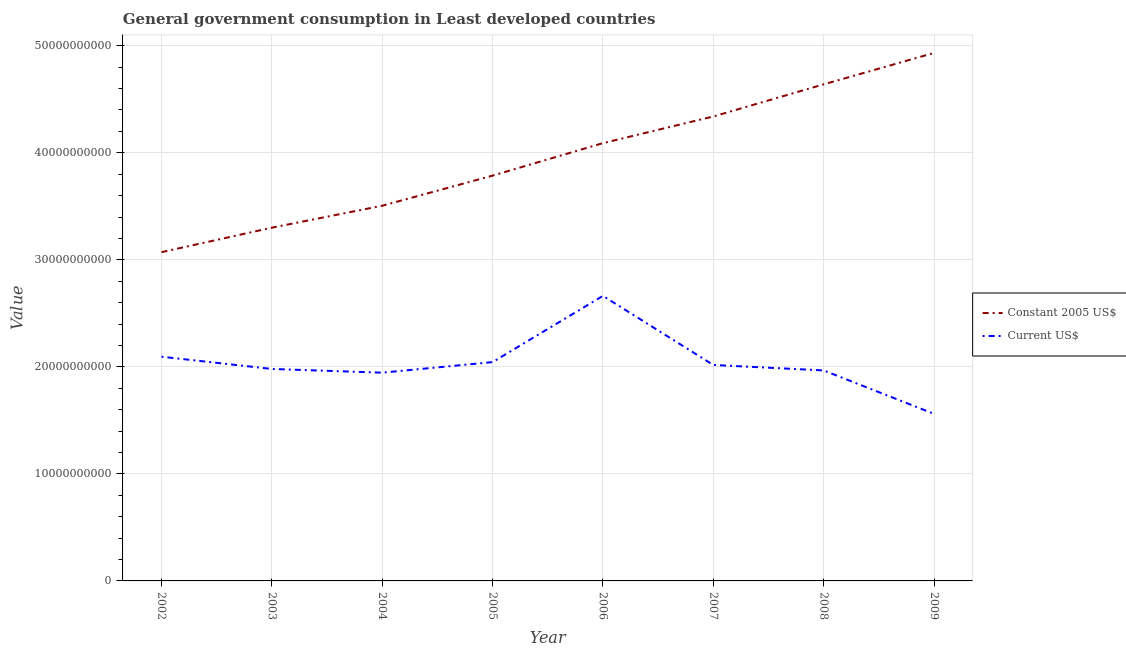How many different coloured lines are there?
Your answer should be compact. 2. What is the value consumed in constant 2005 us$ in 2002?
Offer a very short reply. 3.07e+1. Across all years, what is the maximum value consumed in constant 2005 us$?
Ensure brevity in your answer.  4.93e+1. Across all years, what is the minimum value consumed in current us$?
Your answer should be compact. 1.56e+1. In which year was the value consumed in current us$ maximum?
Your response must be concise. 2006. In which year was the value consumed in constant 2005 us$ minimum?
Your response must be concise. 2002. What is the total value consumed in current us$ in the graph?
Offer a terse response. 1.63e+11. What is the difference between the value consumed in constant 2005 us$ in 2004 and that in 2005?
Keep it short and to the point. -2.81e+09. What is the difference between the value consumed in current us$ in 2007 and the value consumed in constant 2005 us$ in 2008?
Offer a terse response. -2.62e+1. What is the average value consumed in constant 2005 us$ per year?
Your answer should be very brief. 3.96e+1. In the year 2002, what is the difference between the value consumed in current us$ and value consumed in constant 2005 us$?
Ensure brevity in your answer.  -9.77e+09. What is the ratio of the value consumed in current us$ in 2005 to that in 2006?
Give a very brief answer. 0.77. Is the value consumed in constant 2005 us$ in 2004 less than that in 2007?
Provide a short and direct response. Yes. Is the difference between the value consumed in current us$ in 2004 and 2005 greater than the difference between the value consumed in constant 2005 us$ in 2004 and 2005?
Your answer should be compact. Yes. What is the difference between the highest and the second highest value consumed in constant 2005 us$?
Offer a very short reply. 2.94e+09. What is the difference between the highest and the lowest value consumed in current us$?
Your answer should be compact. 1.10e+1. In how many years, is the value consumed in constant 2005 us$ greater than the average value consumed in constant 2005 us$ taken over all years?
Ensure brevity in your answer.  4. Is the sum of the value consumed in constant 2005 us$ in 2004 and 2007 greater than the maximum value consumed in current us$ across all years?
Offer a terse response. Yes. Is the value consumed in current us$ strictly less than the value consumed in constant 2005 us$ over the years?
Ensure brevity in your answer.  Yes. What is the title of the graph?
Your answer should be very brief. General government consumption in Least developed countries. What is the label or title of the X-axis?
Ensure brevity in your answer.  Year. What is the label or title of the Y-axis?
Keep it short and to the point. Value. What is the Value in Constant 2005 US$ in 2002?
Provide a short and direct response. 3.07e+1. What is the Value of Current US$ in 2002?
Your answer should be very brief. 2.09e+1. What is the Value in Constant 2005 US$ in 2003?
Your answer should be compact. 3.30e+1. What is the Value of Current US$ in 2003?
Provide a succinct answer. 1.98e+1. What is the Value in Constant 2005 US$ in 2004?
Offer a terse response. 3.51e+1. What is the Value of Current US$ in 2004?
Your answer should be very brief. 1.95e+1. What is the Value of Constant 2005 US$ in 2005?
Provide a short and direct response. 3.79e+1. What is the Value in Current US$ in 2005?
Your answer should be compact. 2.04e+1. What is the Value in Constant 2005 US$ in 2006?
Your answer should be compact. 4.09e+1. What is the Value of Current US$ in 2006?
Your answer should be compact. 2.66e+1. What is the Value of Constant 2005 US$ in 2007?
Your answer should be very brief. 4.34e+1. What is the Value in Current US$ in 2007?
Your answer should be compact. 2.02e+1. What is the Value of Constant 2005 US$ in 2008?
Give a very brief answer. 4.64e+1. What is the Value in Current US$ in 2008?
Your answer should be compact. 1.97e+1. What is the Value of Constant 2005 US$ in 2009?
Provide a short and direct response. 4.93e+1. What is the Value in Current US$ in 2009?
Your answer should be compact. 1.56e+1. Across all years, what is the maximum Value in Constant 2005 US$?
Give a very brief answer. 4.93e+1. Across all years, what is the maximum Value in Current US$?
Offer a terse response. 2.66e+1. Across all years, what is the minimum Value in Constant 2005 US$?
Offer a very short reply. 3.07e+1. Across all years, what is the minimum Value in Current US$?
Give a very brief answer. 1.56e+1. What is the total Value in Constant 2005 US$ in the graph?
Your answer should be compact. 3.17e+11. What is the total Value in Current US$ in the graph?
Keep it short and to the point. 1.63e+11. What is the difference between the Value of Constant 2005 US$ in 2002 and that in 2003?
Provide a succinct answer. -2.29e+09. What is the difference between the Value of Current US$ in 2002 and that in 2003?
Give a very brief answer. 1.14e+09. What is the difference between the Value in Constant 2005 US$ in 2002 and that in 2004?
Your response must be concise. -4.34e+09. What is the difference between the Value in Current US$ in 2002 and that in 2004?
Your response must be concise. 1.49e+09. What is the difference between the Value of Constant 2005 US$ in 2002 and that in 2005?
Make the answer very short. -7.15e+09. What is the difference between the Value of Current US$ in 2002 and that in 2005?
Ensure brevity in your answer.  5.04e+08. What is the difference between the Value in Constant 2005 US$ in 2002 and that in 2006?
Provide a short and direct response. -1.02e+1. What is the difference between the Value in Current US$ in 2002 and that in 2006?
Offer a very short reply. -5.68e+09. What is the difference between the Value of Constant 2005 US$ in 2002 and that in 2007?
Give a very brief answer. -1.27e+1. What is the difference between the Value of Current US$ in 2002 and that in 2007?
Ensure brevity in your answer.  7.71e+08. What is the difference between the Value of Constant 2005 US$ in 2002 and that in 2008?
Provide a short and direct response. -1.57e+1. What is the difference between the Value in Current US$ in 2002 and that in 2008?
Your answer should be compact. 1.28e+09. What is the difference between the Value in Constant 2005 US$ in 2002 and that in 2009?
Ensure brevity in your answer.  -1.86e+1. What is the difference between the Value of Current US$ in 2002 and that in 2009?
Your answer should be very brief. 5.34e+09. What is the difference between the Value of Constant 2005 US$ in 2003 and that in 2004?
Provide a succinct answer. -2.05e+09. What is the difference between the Value in Current US$ in 2003 and that in 2004?
Your answer should be very brief. 3.47e+08. What is the difference between the Value in Constant 2005 US$ in 2003 and that in 2005?
Provide a short and direct response. -4.86e+09. What is the difference between the Value of Current US$ in 2003 and that in 2005?
Your answer should be compact. -6.39e+08. What is the difference between the Value in Constant 2005 US$ in 2003 and that in 2006?
Your response must be concise. -7.90e+09. What is the difference between the Value in Current US$ in 2003 and that in 2006?
Your answer should be compact. -6.83e+09. What is the difference between the Value in Constant 2005 US$ in 2003 and that in 2007?
Provide a short and direct response. -1.04e+1. What is the difference between the Value of Current US$ in 2003 and that in 2007?
Offer a terse response. -3.72e+08. What is the difference between the Value of Constant 2005 US$ in 2003 and that in 2008?
Your response must be concise. -1.34e+1. What is the difference between the Value in Current US$ in 2003 and that in 2008?
Provide a succinct answer. 1.39e+08. What is the difference between the Value in Constant 2005 US$ in 2003 and that in 2009?
Make the answer very short. -1.63e+1. What is the difference between the Value of Current US$ in 2003 and that in 2009?
Offer a very short reply. 4.20e+09. What is the difference between the Value of Constant 2005 US$ in 2004 and that in 2005?
Your answer should be compact. -2.81e+09. What is the difference between the Value in Current US$ in 2004 and that in 2005?
Provide a succinct answer. -9.87e+08. What is the difference between the Value in Constant 2005 US$ in 2004 and that in 2006?
Provide a short and direct response. -5.85e+09. What is the difference between the Value of Current US$ in 2004 and that in 2006?
Make the answer very short. -7.17e+09. What is the difference between the Value in Constant 2005 US$ in 2004 and that in 2007?
Make the answer very short. -8.34e+09. What is the difference between the Value of Current US$ in 2004 and that in 2007?
Your answer should be very brief. -7.20e+08. What is the difference between the Value of Constant 2005 US$ in 2004 and that in 2008?
Give a very brief answer. -1.13e+1. What is the difference between the Value in Current US$ in 2004 and that in 2008?
Offer a terse response. -2.09e+08. What is the difference between the Value in Constant 2005 US$ in 2004 and that in 2009?
Offer a terse response. -1.43e+1. What is the difference between the Value in Current US$ in 2004 and that in 2009?
Make the answer very short. 3.85e+09. What is the difference between the Value in Constant 2005 US$ in 2005 and that in 2006?
Give a very brief answer. -3.04e+09. What is the difference between the Value of Current US$ in 2005 and that in 2006?
Your response must be concise. -6.19e+09. What is the difference between the Value of Constant 2005 US$ in 2005 and that in 2007?
Offer a terse response. -5.53e+09. What is the difference between the Value in Current US$ in 2005 and that in 2007?
Give a very brief answer. 2.67e+08. What is the difference between the Value of Constant 2005 US$ in 2005 and that in 2008?
Make the answer very short. -8.53e+09. What is the difference between the Value of Current US$ in 2005 and that in 2008?
Offer a terse response. 7.78e+08. What is the difference between the Value of Constant 2005 US$ in 2005 and that in 2009?
Ensure brevity in your answer.  -1.15e+1. What is the difference between the Value of Current US$ in 2005 and that in 2009?
Keep it short and to the point. 4.83e+09. What is the difference between the Value of Constant 2005 US$ in 2006 and that in 2007?
Give a very brief answer. -2.49e+09. What is the difference between the Value of Current US$ in 2006 and that in 2007?
Ensure brevity in your answer.  6.45e+09. What is the difference between the Value of Constant 2005 US$ in 2006 and that in 2008?
Your answer should be very brief. -5.49e+09. What is the difference between the Value of Current US$ in 2006 and that in 2008?
Make the answer very short. 6.97e+09. What is the difference between the Value in Constant 2005 US$ in 2006 and that in 2009?
Your response must be concise. -8.43e+09. What is the difference between the Value in Current US$ in 2006 and that in 2009?
Ensure brevity in your answer.  1.10e+1. What is the difference between the Value of Constant 2005 US$ in 2007 and that in 2008?
Give a very brief answer. -3.00e+09. What is the difference between the Value of Current US$ in 2007 and that in 2008?
Give a very brief answer. 5.11e+08. What is the difference between the Value in Constant 2005 US$ in 2007 and that in 2009?
Give a very brief answer. -5.94e+09. What is the difference between the Value of Current US$ in 2007 and that in 2009?
Give a very brief answer. 4.57e+09. What is the difference between the Value of Constant 2005 US$ in 2008 and that in 2009?
Provide a short and direct response. -2.94e+09. What is the difference between the Value in Current US$ in 2008 and that in 2009?
Offer a very short reply. 4.06e+09. What is the difference between the Value of Constant 2005 US$ in 2002 and the Value of Current US$ in 2003?
Make the answer very short. 1.09e+1. What is the difference between the Value of Constant 2005 US$ in 2002 and the Value of Current US$ in 2004?
Offer a terse response. 1.13e+1. What is the difference between the Value in Constant 2005 US$ in 2002 and the Value in Current US$ in 2005?
Provide a succinct answer. 1.03e+1. What is the difference between the Value of Constant 2005 US$ in 2002 and the Value of Current US$ in 2006?
Your answer should be compact. 4.08e+09. What is the difference between the Value of Constant 2005 US$ in 2002 and the Value of Current US$ in 2007?
Your response must be concise. 1.05e+1. What is the difference between the Value of Constant 2005 US$ in 2002 and the Value of Current US$ in 2008?
Provide a short and direct response. 1.10e+1. What is the difference between the Value in Constant 2005 US$ in 2002 and the Value in Current US$ in 2009?
Offer a very short reply. 1.51e+1. What is the difference between the Value in Constant 2005 US$ in 2003 and the Value in Current US$ in 2004?
Your answer should be very brief. 1.35e+1. What is the difference between the Value of Constant 2005 US$ in 2003 and the Value of Current US$ in 2005?
Give a very brief answer. 1.26e+1. What is the difference between the Value in Constant 2005 US$ in 2003 and the Value in Current US$ in 2006?
Give a very brief answer. 6.37e+09. What is the difference between the Value in Constant 2005 US$ in 2003 and the Value in Current US$ in 2007?
Keep it short and to the point. 1.28e+1. What is the difference between the Value in Constant 2005 US$ in 2003 and the Value in Current US$ in 2008?
Your answer should be very brief. 1.33e+1. What is the difference between the Value of Constant 2005 US$ in 2003 and the Value of Current US$ in 2009?
Provide a succinct answer. 1.74e+1. What is the difference between the Value of Constant 2005 US$ in 2004 and the Value of Current US$ in 2005?
Keep it short and to the point. 1.46e+1. What is the difference between the Value of Constant 2005 US$ in 2004 and the Value of Current US$ in 2006?
Provide a succinct answer. 8.42e+09. What is the difference between the Value in Constant 2005 US$ in 2004 and the Value in Current US$ in 2007?
Offer a very short reply. 1.49e+1. What is the difference between the Value in Constant 2005 US$ in 2004 and the Value in Current US$ in 2008?
Make the answer very short. 1.54e+1. What is the difference between the Value of Constant 2005 US$ in 2004 and the Value of Current US$ in 2009?
Offer a very short reply. 1.94e+1. What is the difference between the Value of Constant 2005 US$ in 2005 and the Value of Current US$ in 2006?
Keep it short and to the point. 1.12e+1. What is the difference between the Value of Constant 2005 US$ in 2005 and the Value of Current US$ in 2007?
Offer a terse response. 1.77e+1. What is the difference between the Value in Constant 2005 US$ in 2005 and the Value in Current US$ in 2008?
Provide a succinct answer. 1.82e+1. What is the difference between the Value in Constant 2005 US$ in 2005 and the Value in Current US$ in 2009?
Offer a terse response. 2.23e+1. What is the difference between the Value in Constant 2005 US$ in 2006 and the Value in Current US$ in 2007?
Ensure brevity in your answer.  2.07e+1. What is the difference between the Value of Constant 2005 US$ in 2006 and the Value of Current US$ in 2008?
Make the answer very short. 2.12e+1. What is the difference between the Value in Constant 2005 US$ in 2006 and the Value in Current US$ in 2009?
Your answer should be very brief. 2.53e+1. What is the difference between the Value of Constant 2005 US$ in 2007 and the Value of Current US$ in 2008?
Your answer should be very brief. 2.37e+1. What is the difference between the Value in Constant 2005 US$ in 2007 and the Value in Current US$ in 2009?
Ensure brevity in your answer.  2.78e+1. What is the difference between the Value in Constant 2005 US$ in 2008 and the Value in Current US$ in 2009?
Give a very brief answer. 3.08e+1. What is the average Value in Constant 2005 US$ per year?
Provide a succinct answer. 3.96e+1. What is the average Value of Current US$ per year?
Your answer should be very brief. 2.03e+1. In the year 2002, what is the difference between the Value in Constant 2005 US$ and Value in Current US$?
Keep it short and to the point. 9.77e+09. In the year 2003, what is the difference between the Value of Constant 2005 US$ and Value of Current US$?
Make the answer very short. 1.32e+1. In the year 2004, what is the difference between the Value in Constant 2005 US$ and Value in Current US$?
Your answer should be compact. 1.56e+1. In the year 2005, what is the difference between the Value of Constant 2005 US$ and Value of Current US$?
Your response must be concise. 1.74e+1. In the year 2006, what is the difference between the Value of Constant 2005 US$ and Value of Current US$?
Make the answer very short. 1.43e+1. In the year 2007, what is the difference between the Value in Constant 2005 US$ and Value in Current US$?
Your answer should be very brief. 2.32e+1. In the year 2008, what is the difference between the Value in Constant 2005 US$ and Value in Current US$?
Make the answer very short. 2.67e+1. In the year 2009, what is the difference between the Value in Constant 2005 US$ and Value in Current US$?
Offer a terse response. 3.37e+1. What is the ratio of the Value in Constant 2005 US$ in 2002 to that in 2003?
Offer a very short reply. 0.93. What is the ratio of the Value of Current US$ in 2002 to that in 2003?
Keep it short and to the point. 1.06. What is the ratio of the Value of Constant 2005 US$ in 2002 to that in 2004?
Provide a short and direct response. 0.88. What is the ratio of the Value of Current US$ in 2002 to that in 2004?
Make the answer very short. 1.08. What is the ratio of the Value of Constant 2005 US$ in 2002 to that in 2005?
Your response must be concise. 0.81. What is the ratio of the Value in Current US$ in 2002 to that in 2005?
Keep it short and to the point. 1.02. What is the ratio of the Value of Constant 2005 US$ in 2002 to that in 2006?
Offer a terse response. 0.75. What is the ratio of the Value in Current US$ in 2002 to that in 2006?
Your response must be concise. 0.79. What is the ratio of the Value of Constant 2005 US$ in 2002 to that in 2007?
Your answer should be very brief. 0.71. What is the ratio of the Value of Current US$ in 2002 to that in 2007?
Your answer should be very brief. 1.04. What is the ratio of the Value in Constant 2005 US$ in 2002 to that in 2008?
Give a very brief answer. 0.66. What is the ratio of the Value in Current US$ in 2002 to that in 2008?
Your answer should be compact. 1.07. What is the ratio of the Value in Constant 2005 US$ in 2002 to that in 2009?
Give a very brief answer. 0.62. What is the ratio of the Value of Current US$ in 2002 to that in 2009?
Offer a very short reply. 1.34. What is the ratio of the Value of Constant 2005 US$ in 2003 to that in 2004?
Provide a short and direct response. 0.94. What is the ratio of the Value of Current US$ in 2003 to that in 2004?
Give a very brief answer. 1.02. What is the ratio of the Value in Constant 2005 US$ in 2003 to that in 2005?
Offer a terse response. 0.87. What is the ratio of the Value of Current US$ in 2003 to that in 2005?
Provide a succinct answer. 0.97. What is the ratio of the Value of Constant 2005 US$ in 2003 to that in 2006?
Keep it short and to the point. 0.81. What is the ratio of the Value of Current US$ in 2003 to that in 2006?
Offer a terse response. 0.74. What is the ratio of the Value of Constant 2005 US$ in 2003 to that in 2007?
Provide a short and direct response. 0.76. What is the ratio of the Value in Current US$ in 2003 to that in 2007?
Provide a short and direct response. 0.98. What is the ratio of the Value in Constant 2005 US$ in 2003 to that in 2008?
Give a very brief answer. 0.71. What is the ratio of the Value in Current US$ in 2003 to that in 2008?
Your answer should be compact. 1.01. What is the ratio of the Value in Constant 2005 US$ in 2003 to that in 2009?
Your answer should be compact. 0.67. What is the ratio of the Value of Current US$ in 2003 to that in 2009?
Your answer should be very brief. 1.27. What is the ratio of the Value of Constant 2005 US$ in 2004 to that in 2005?
Offer a terse response. 0.93. What is the ratio of the Value in Current US$ in 2004 to that in 2005?
Provide a short and direct response. 0.95. What is the ratio of the Value of Constant 2005 US$ in 2004 to that in 2006?
Provide a succinct answer. 0.86. What is the ratio of the Value in Current US$ in 2004 to that in 2006?
Make the answer very short. 0.73. What is the ratio of the Value in Constant 2005 US$ in 2004 to that in 2007?
Give a very brief answer. 0.81. What is the ratio of the Value of Constant 2005 US$ in 2004 to that in 2008?
Provide a succinct answer. 0.76. What is the ratio of the Value in Constant 2005 US$ in 2004 to that in 2009?
Keep it short and to the point. 0.71. What is the ratio of the Value of Current US$ in 2004 to that in 2009?
Make the answer very short. 1.25. What is the ratio of the Value in Constant 2005 US$ in 2005 to that in 2006?
Your response must be concise. 0.93. What is the ratio of the Value in Current US$ in 2005 to that in 2006?
Give a very brief answer. 0.77. What is the ratio of the Value in Constant 2005 US$ in 2005 to that in 2007?
Make the answer very short. 0.87. What is the ratio of the Value of Current US$ in 2005 to that in 2007?
Offer a terse response. 1.01. What is the ratio of the Value of Constant 2005 US$ in 2005 to that in 2008?
Your response must be concise. 0.82. What is the ratio of the Value in Current US$ in 2005 to that in 2008?
Make the answer very short. 1.04. What is the ratio of the Value in Constant 2005 US$ in 2005 to that in 2009?
Make the answer very short. 0.77. What is the ratio of the Value of Current US$ in 2005 to that in 2009?
Your answer should be compact. 1.31. What is the ratio of the Value of Constant 2005 US$ in 2006 to that in 2007?
Offer a very short reply. 0.94. What is the ratio of the Value in Current US$ in 2006 to that in 2007?
Your answer should be very brief. 1.32. What is the ratio of the Value of Constant 2005 US$ in 2006 to that in 2008?
Make the answer very short. 0.88. What is the ratio of the Value of Current US$ in 2006 to that in 2008?
Your answer should be compact. 1.35. What is the ratio of the Value of Constant 2005 US$ in 2006 to that in 2009?
Make the answer very short. 0.83. What is the ratio of the Value in Current US$ in 2006 to that in 2009?
Keep it short and to the point. 1.71. What is the ratio of the Value in Constant 2005 US$ in 2007 to that in 2008?
Ensure brevity in your answer.  0.94. What is the ratio of the Value in Constant 2005 US$ in 2007 to that in 2009?
Your answer should be very brief. 0.88. What is the ratio of the Value in Current US$ in 2007 to that in 2009?
Provide a short and direct response. 1.29. What is the ratio of the Value of Constant 2005 US$ in 2008 to that in 2009?
Provide a short and direct response. 0.94. What is the ratio of the Value in Current US$ in 2008 to that in 2009?
Offer a terse response. 1.26. What is the difference between the highest and the second highest Value in Constant 2005 US$?
Give a very brief answer. 2.94e+09. What is the difference between the highest and the second highest Value of Current US$?
Keep it short and to the point. 5.68e+09. What is the difference between the highest and the lowest Value in Constant 2005 US$?
Your answer should be compact. 1.86e+1. What is the difference between the highest and the lowest Value of Current US$?
Your answer should be very brief. 1.10e+1. 